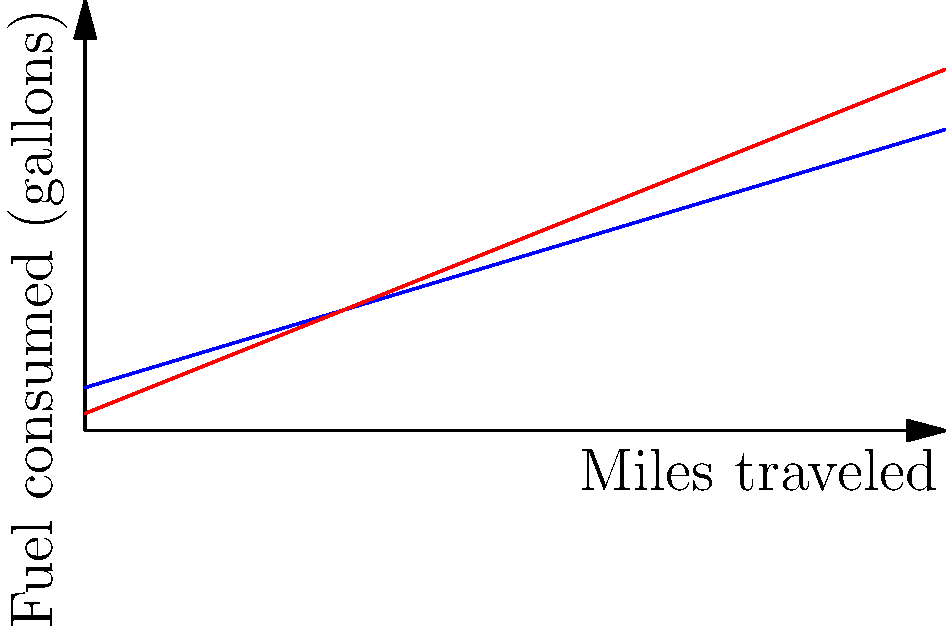The graph shows fuel consumption curves for two types of locomotives: diesel-electric and steam. If a train needs to travel 200 miles, how many more gallons of fuel would a steam locomotive consume compared to a diesel-electric locomotive? To solve this problem, we need to follow these steps:

1. Identify the equations for fuel consumption:
   - Diesel-electric: $y = 0.3x + 5$
   - Steam: $y = 0.4x + 2$

2. Calculate fuel consumption for diesel-electric locomotive:
   $y = 0.3(200) + 5 = 60 + 5 = 65$ gallons

3. Calculate fuel consumption for steam locomotive:
   $y = 0.4(200) + 2 = 80 + 2 = 82$ gallons

4. Find the difference in fuel consumption:
   $82 - 65 = 17$ gallons

Therefore, the steam locomotive would consume 17 more gallons of fuel than the diesel-electric locomotive for a 200-mile journey.
Answer: 17 gallons 